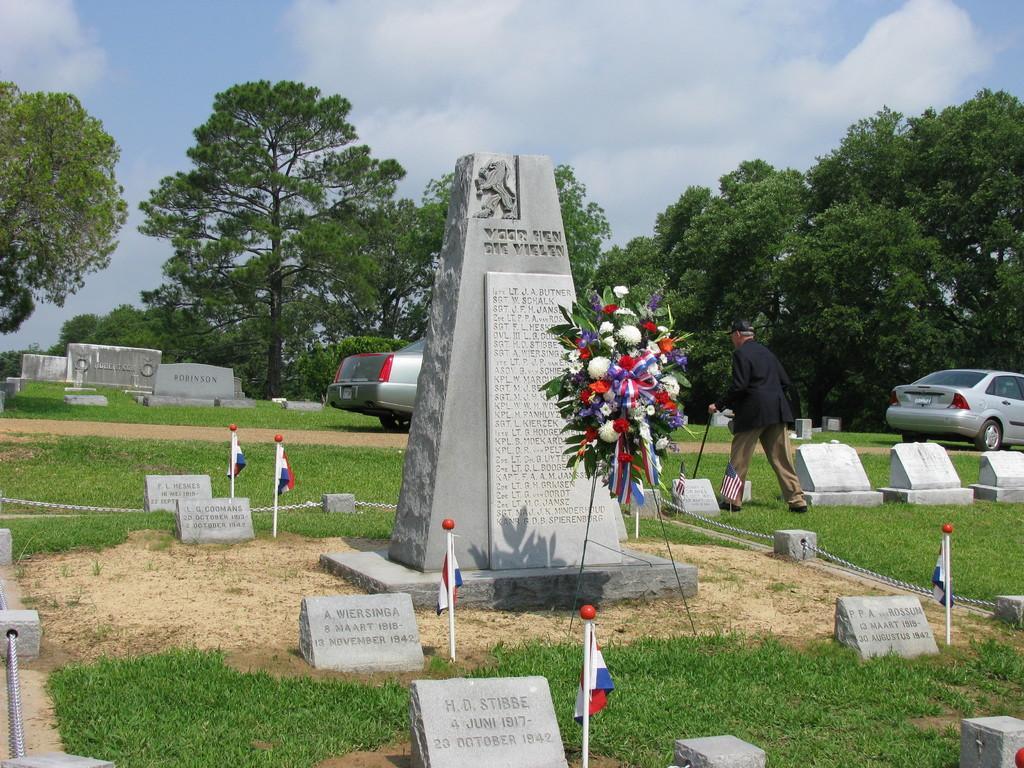Could you give a brief overview of what you see in this image? In this image I can see few monuments, flags, trees and vehicles. One person is walking and holding a sticks. The sky is in white and blue color. 